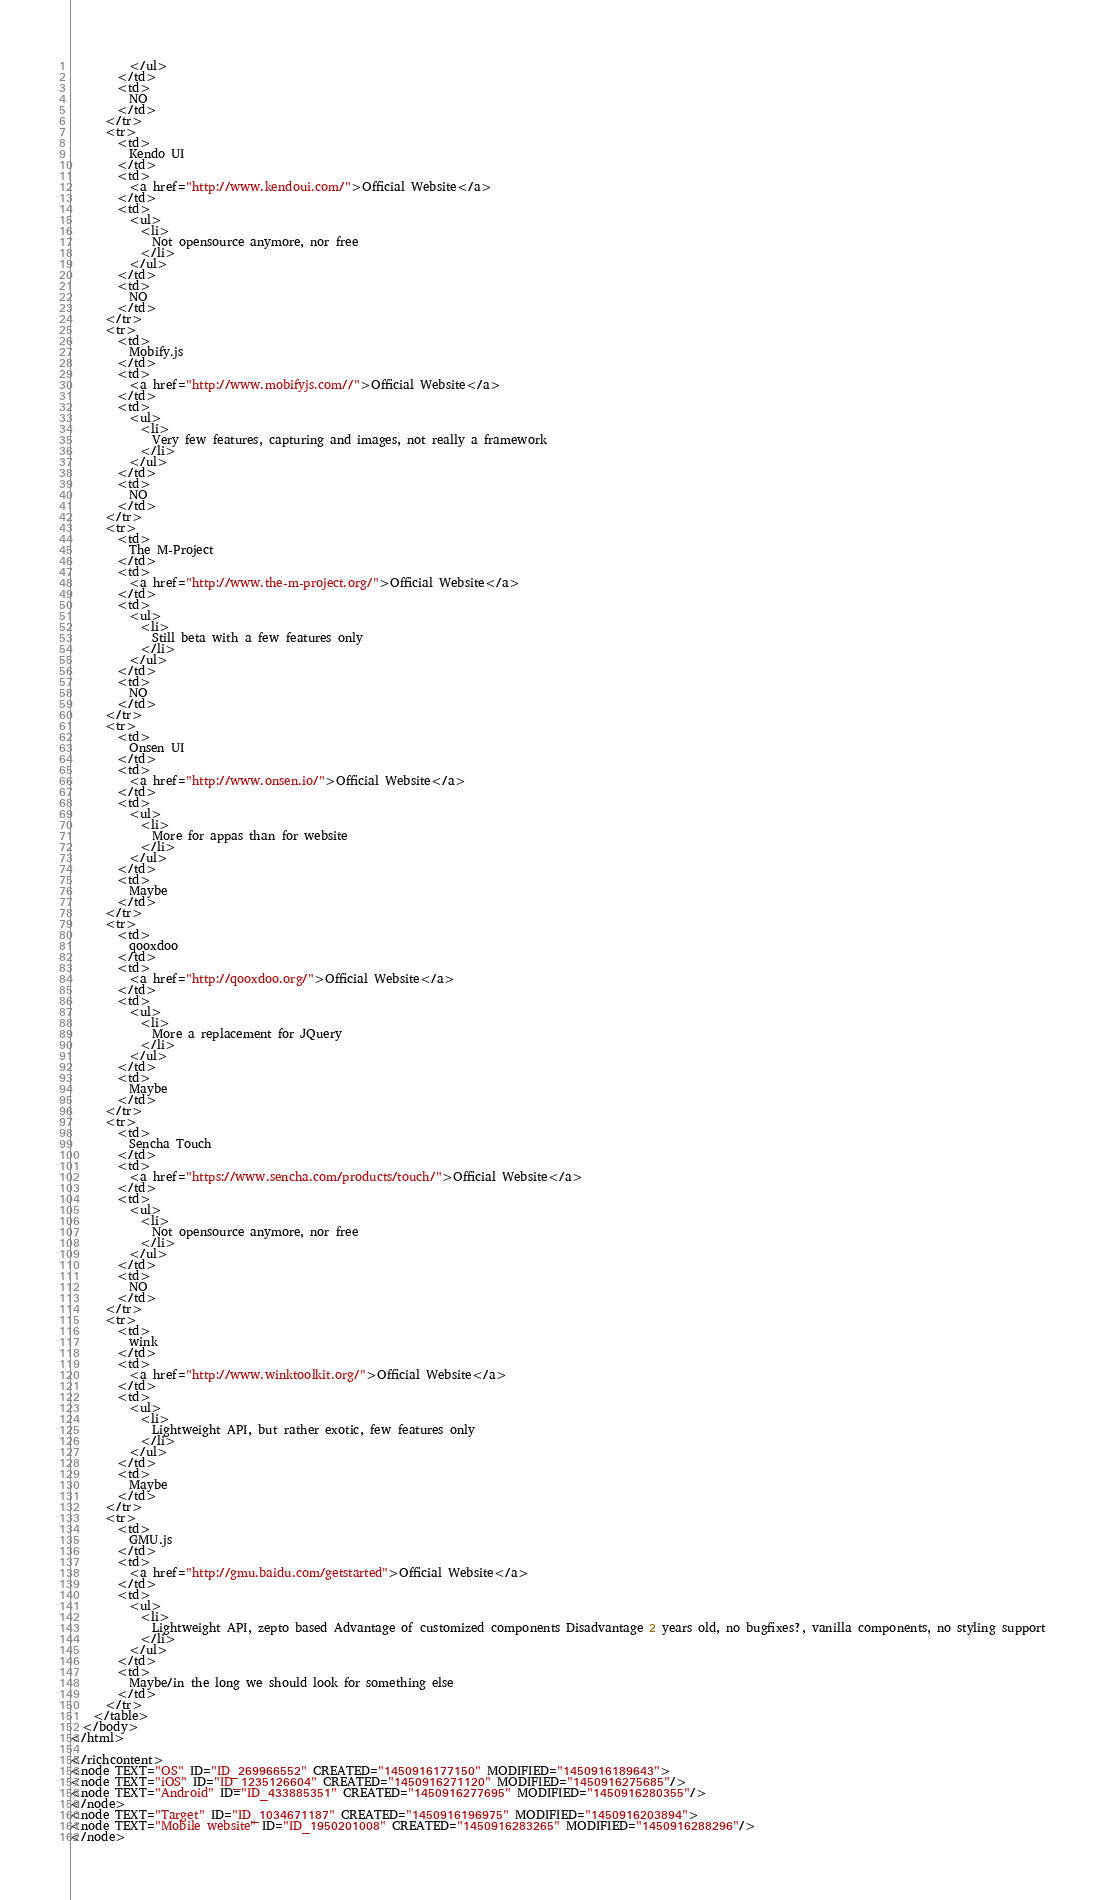Convert code to text. <code><loc_0><loc_0><loc_500><loc_500><_ObjectiveC_>          </ul>
        </td>
        <td>
          NO
        </td>
      </tr>
      <tr>
        <td>
          Kendo UI
        </td>
        <td>
          <a href="http://www.kendoui.com/">Official Website</a>
        </td>
        <td>
          <ul>
            <li>
              Not opensource anymore, nor free
            </li>
          </ul>
        </td>
        <td>
          NO
        </td>
      </tr>
      <tr>
        <td>
          Mobify.js
        </td>
        <td>
          <a href="http://www.mobifyjs.com//">Official Website</a>
        </td>
        <td>
          <ul>
            <li>
              Very few features, capturing and images, not really a framework
            </li>
          </ul>
        </td>
        <td>
          NO
        </td>
      </tr>
      <tr>
        <td>
          The M-Project
        </td>
        <td>
          <a href="http://www.the-m-project.org/">Official Website</a>
        </td>
        <td>
          <ul>
            <li>
              Still beta with a few features only
            </li>
          </ul>
        </td>
        <td>
          NO
        </td>
      </tr>
      <tr>
        <td>
          Onsen UI
        </td>
        <td>
          <a href="http://www.onsen.io/">Official Website</a>
        </td>
        <td>
          <ul>
            <li>
              More for appas than for website
            </li>
          </ul>
        </td>
        <td>
          Maybe
        </td>
      </tr>
      <tr>
        <td>
          qooxdoo
        </td>
        <td>
          <a href="http://qooxdoo.org/">Official Website</a>
        </td>
        <td>
          <ul>
            <li>
              More a replacement for JQuery
            </li>
          </ul>
        </td>
        <td>
          Maybe
        </td>
      </tr>
      <tr>
        <td>
          Sencha Touch
        </td>
        <td>
          <a href="https://www.sencha.com/products/touch/">Official Website</a>
        </td>
        <td>
          <ul>
            <li>
              Not opensource anymore, nor free
            </li>
          </ul>
        </td>
        <td>
          NO
        </td>
      </tr>
      <tr>
        <td>
          wink
        </td>
        <td>
          <a href="http://www.winktoolkit.org/">Official Website</a>
        </td>
        <td>
          <ul>
            <li>
              Lightweight API, but rather exotic, few features only
            </li>
          </ul>
        </td>
        <td>
          Maybe
        </td>
      </tr>
      <tr>
        <td>
          GMU.js
        </td>
        <td>
          <a href="http://gmu.baidu.com/getstarted">Official Website</a>
        </td>
        <td>
          <ul>
            <li>
              Lightweight API, zepto based Advantage of customized components Disadvantage 2 years old, no bugfixes?, vanilla components, no styling support
            </li>
          </ul>
        </td>
        <td>
          Maybe/in the long we should look for something else
        </td>
      </tr>
    </table>
  </body>
</html>

</richcontent>
<node TEXT="OS" ID="ID_269966552" CREATED="1450916177150" MODIFIED="1450916189643">
<node TEXT="iOS" ID="ID_1235126604" CREATED="1450916271120" MODIFIED="1450916275685"/>
<node TEXT="Android" ID="ID_433885351" CREATED="1450916277695" MODIFIED="1450916280355"/>
</node>
<node TEXT="Target" ID="ID_1034671187" CREATED="1450916196975" MODIFIED="1450916203894">
<node TEXT="Mobile website" ID="ID_1950201008" CREATED="1450916283265" MODIFIED="1450916288296"/>
</node></code> 